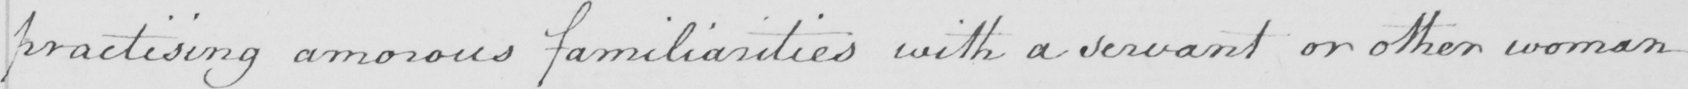What is written in this line of handwriting? practising amorous familiarities with a servant or other woman 